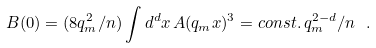Convert formula to latex. <formula><loc_0><loc_0><loc_500><loc_500>B ( 0 ) = ( 8 q _ { m } ^ { 2 } / n ) \int d ^ { d } x \, A ( q _ { m } x ) ^ { 3 } = c o n s t . \, q _ { m } ^ { 2 - d } / n \ .</formula> 